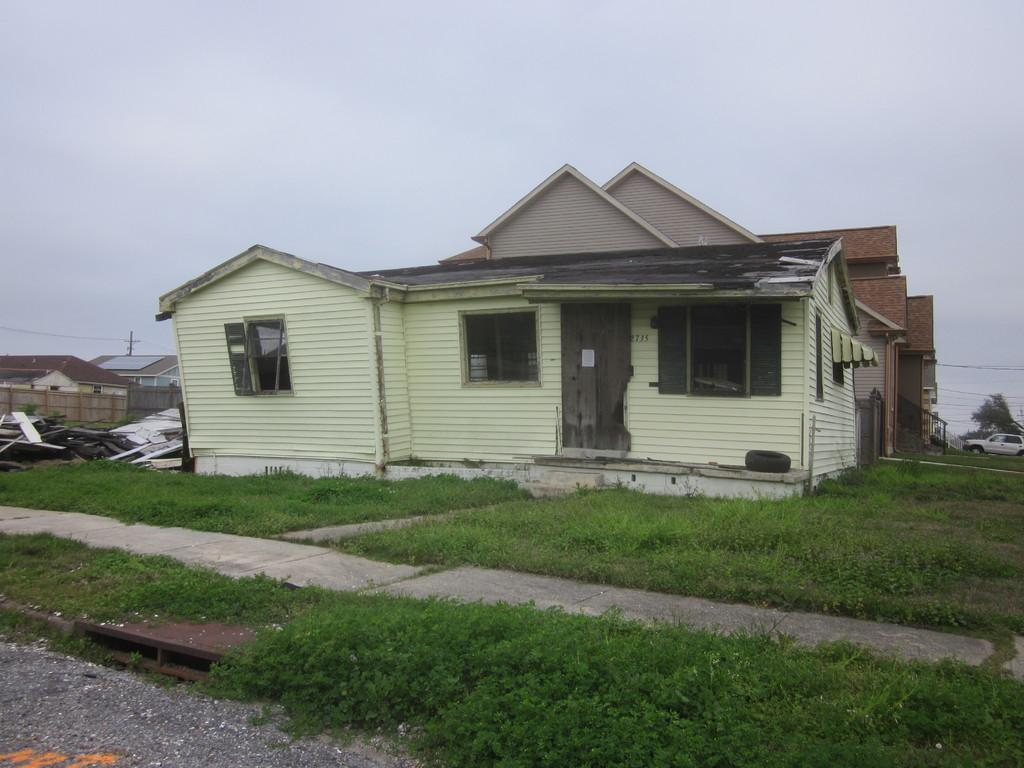What type of house is in the image? There is a wooden house in the image. What is at the bottom of the image? There is grass at the bottom of the image. What can be seen in the sky in the image? The sky is cloudy and visible at the top of the image. What color is the sweater worn by the person in the image? There is no person wearing a sweater in the image. What type of noise can be heard coming from the house in the image? There is no noise or indication of sound in the image. 